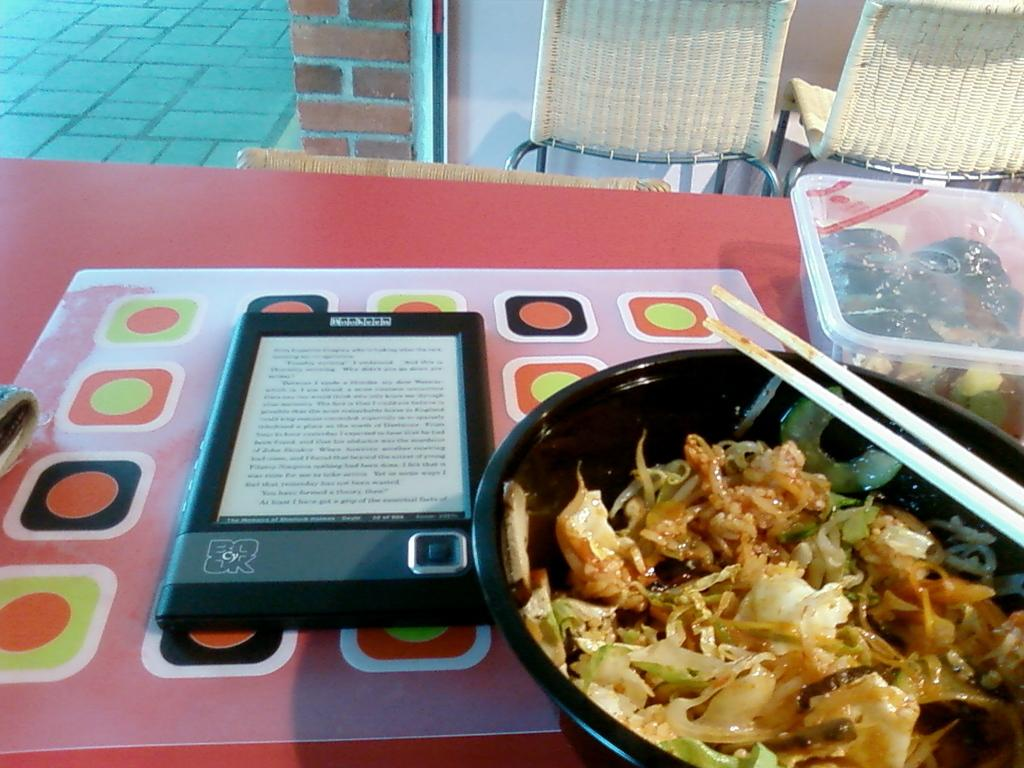What type of furniture is visible in the image? There is a table in the image. What is placed on the table? There are bowls, a box, chopsticks, food items, and a tab on the table. What type of utensils are present on the table? Chopsticks are present on the table. What is the setting of the image? There is a wall, a floor, and chairs in the image. What type of popcorn is being served to the boy in the image? There is no boy or popcorn present in the image. 